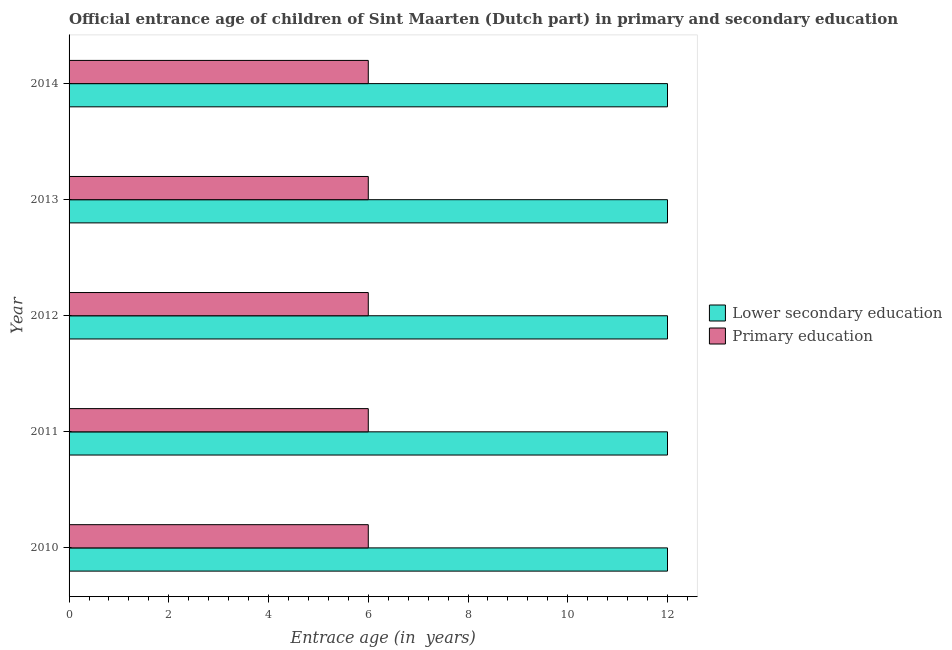How many groups of bars are there?
Your response must be concise. 5. What is the label of the 4th group of bars from the top?
Offer a very short reply. 2011. What is the entrance age of children in lower secondary education in 2014?
Your response must be concise. 12. Across all years, what is the maximum entrance age of chiildren in primary education?
Offer a very short reply. 6. Across all years, what is the minimum entrance age of children in lower secondary education?
Provide a short and direct response. 12. What is the total entrance age of chiildren in primary education in the graph?
Keep it short and to the point. 30. What is the difference between the entrance age of chiildren in primary education in 2012 and that in 2013?
Offer a very short reply. 0. What is the difference between the entrance age of chiildren in primary education in 2013 and the entrance age of children in lower secondary education in 2014?
Offer a very short reply. -6. In how many years, is the entrance age of chiildren in primary education greater than 8 years?
Provide a short and direct response. 0. What is the ratio of the entrance age of chiildren in primary education in 2010 to that in 2014?
Ensure brevity in your answer.  1. Is the entrance age of children in lower secondary education in 2011 less than that in 2013?
Ensure brevity in your answer.  No. Is the difference between the entrance age of children in lower secondary education in 2011 and 2014 greater than the difference between the entrance age of chiildren in primary education in 2011 and 2014?
Your answer should be compact. No. What is the difference between the highest and the second highest entrance age of children in lower secondary education?
Your answer should be very brief. 0. What is the difference between the highest and the lowest entrance age of chiildren in primary education?
Provide a short and direct response. 0. In how many years, is the entrance age of chiildren in primary education greater than the average entrance age of chiildren in primary education taken over all years?
Provide a succinct answer. 0. Is the sum of the entrance age of chiildren in primary education in 2012 and 2014 greater than the maximum entrance age of children in lower secondary education across all years?
Ensure brevity in your answer.  No. What does the 2nd bar from the top in 2010 represents?
Give a very brief answer. Lower secondary education. How many years are there in the graph?
Offer a very short reply. 5. Are the values on the major ticks of X-axis written in scientific E-notation?
Provide a short and direct response. No. Where does the legend appear in the graph?
Make the answer very short. Center right. How are the legend labels stacked?
Your answer should be compact. Vertical. What is the title of the graph?
Your response must be concise. Official entrance age of children of Sint Maarten (Dutch part) in primary and secondary education. What is the label or title of the X-axis?
Make the answer very short. Entrace age (in  years). What is the Entrace age (in  years) in Lower secondary education in 2011?
Provide a succinct answer. 12. What is the Entrace age (in  years) in Primary education in 2011?
Offer a terse response. 6. What is the Entrace age (in  years) in Lower secondary education in 2012?
Give a very brief answer. 12. What is the Entrace age (in  years) of Primary education in 2012?
Provide a succinct answer. 6. What is the Entrace age (in  years) in Lower secondary education in 2013?
Provide a succinct answer. 12. What is the Entrace age (in  years) in Lower secondary education in 2014?
Your response must be concise. 12. Across all years, what is the maximum Entrace age (in  years) of Lower secondary education?
Provide a short and direct response. 12. Across all years, what is the maximum Entrace age (in  years) of Primary education?
Your response must be concise. 6. What is the total Entrace age (in  years) in Primary education in the graph?
Make the answer very short. 30. What is the difference between the Entrace age (in  years) in Lower secondary education in 2010 and that in 2011?
Your answer should be compact. 0. What is the difference between the Entrace age (in  years) in Primary education in 2010 and that in 2012?
Make the answer very short. 0. What is the difference between the Entrace age (in  years) of Primary education in 2010 and that in 2013?
Offer a very short reply. 0. What is the difference between the Entrace age (in  years) in Lower secondary education in 2010 and that in 2014?
Keep it short and to the point. 0. What is the difference between the Entrace age (in  years) of Primary education in 2010 and that in 2014?
Your response must be concise. 0. What is the difference between the Entrace age (in  years) of Lower secondary education in 2011 and that in 2012?
Provide a succinct answer. 0. What is the difference between the Entrace age (in  years) of Lower secondary education in 2011 and that in 2014?
Ensure brevity in your answer.  0. What is the difference between the Entrace age (in  years) of Primary education in 2011 and that in 2014?
Make the answer very short. 0. What is the difference between the Entrace age (in  years) in Lower secondary education in 2012 and that in 2013?
Provide a short and direct response. 0. What is the difference between the Entrace age (in  years) in Lower secondary education in 2012 and that in 2014?
Ensure brevity in your answer.  0. What is the difference between the Entrace age (in  years) in Primary education in 2013 and that in 2014?
Provide a succinct answer. 0. What is the difference between the Entrace age (in  years) in Lower secondary education in 2010 and the Entrace age (in  years) in Primary education in 2011?
Your response must be concise. 6. What is the difference between the Entrace age (in  years) of Lower secondary education in 2010 and the Entrace age (in  years) of Primary education in 2014?
Make the answer very short. 6. What is the difference between the Entrace age (in  years) in Lower secondary education in 2011 and the Entrace age (in  years) in Primary education in 2012?
Your response must be concise. 6. What is the difference between the Entrace age (in  years) of Lower secondary education in 2011 and the Entrace age (in  years) of Primary education in 2013?
Give a very brief answer. 6. What is the difference between the Entrace age (in  years) of Lower secondary education in 2012 and the Entrace age (in  years) of Primary education in 2013?
Offer a terse response. 6. What is the difference between the Entrace age (in  years) in Lower secondary education in 2013 and the Entrace age (in  years) in Primary education in 2014?
Give a very brief answer. 6. What is the average Entrace age (in  years) in Lower secondary education per year?
Provide a short and direct response. 12. In the year 2011, what is the difference between the Entrace age (in  years) of Lower secondary education and Entrace age (in  years) of Primary education?
Your answer should be very brief. 6. In the year 2012, what is the difference between the Entrace age (in  years) in Lower secondary education and Entrace age (in  years) in Primary education?
Make the answer very short. 6. In the year 2013, what is the difference between the Entrace age (in  years) in Lower secondary education and Entrace age (in  years) in Primary education?
Ensure brevity in your answer.  6. In the year 2014, what is the difference between the Entrace age (in  years) in Lower secondary education and Entrace age (in  years) in Primary education?
Offer a terse response. 6. What is the ratio of the Entrace age (in  years) of Primary education in 2010 to that in 2011?
Make the answer very short. 1. What is the ratio of the Entrace age (in  years) of Lower secondary education in 2010 to that in 2012?
Give a very brief answer. 1. What is the ratio of the Entrace age (in  years) of Primary education in 2010 to that in 2012?
Make the answer very short. 1. What is the ratio of the Entrace age (in  years) of Lower secondary education in 2010 to that in 2013?
Provide a succinct answer. 1. What is the ratio of the Entrace age (in  years) in Primary education in 2010 to that in 2013?
Offer a terse response. 1. What is the ratio of the Entrace age (in  years) in Lower secondary education in 2011 to that in 2012?
Your response must be concise. 1. What is the ratio of the Entrace age (in  years) in Primary education in 2011 to that in 2012?
Give a very brief answer. 1. What is the ratio of the Entrace age (in  years) of Lower secondary education in 2011 to that in 2013?
Provide a short and direct response. 1. What is the ratio of the Entrace age (in  years) of Primary education in 2011 to that in 2013?
Offer a very short reply. 1. What is the ratio of the Entrace age (in  years) of Lower secondary education in 2011 to that in 2014?
Make the answer very short. 1. What is the ratio of the Entrace age (in  years) of Primary education in 2011 to that in 2014?
Offer a very short reply. 1. What is the ratio of the Entrace age (in  years) in Lower secondary education in 2012 to that in 2013?
Your response must be concise. 1. What is the ratio of the Entrace age (in  years) of Primary education in 2012 to that in 2013?
Make the answer very short. 1. What is the ratio of the Entrace age (in  years) in Lower secondary education in 2013 to that in 2014?
Offer a terse response. 1. What is the difference between the highest and the second highest Entrace age (in  years) in Lower secondary education?
Ensure brevity in your answer.  0. What is the difference between the highest and the second highest Entrace age (in  years) in Primary education?
Make the answer very short. 0. What is the difference between the highest and the lowest Entrace age (in  years) of Primary education?
Your answer should be compact. 0. 